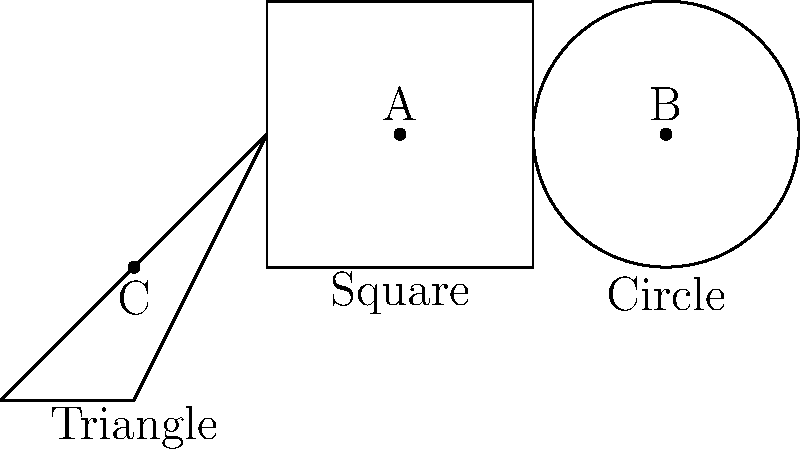As a retired firefighter with an eye for both functionality and architecture, you're consulting on the design of a new fire station. Three floor plan shapes are proposed: a square, a circle, and an equilateral triangle, each with the same area of 100 m². If point A is the center of the square, B is the center of the circle, and C is the centroid of the triangle, which shape would allow for the quickest average response time, assuming firefighters start from the center point? To determine the shape with the quickest average response time, we need to compare the average distance from the center to any point within each shape. This is related to the concept of the "mean radius" for each shape.

1. Square:
   - Side length: $\sqrt{100} = 10$ m
   - Mean radius ≈ 0.383 × side length
   - Mean radius ≈ 0.383 × 10 ≈ 3.83 m

2. Circle:
   - Radius: $r = \sqrt{\frac{100}{\pi}} ≈ 5.64$ m
   - Mean radius = $\frac{2}{3}r ≈ 3.76$ m

3. Equilateral Triangle:
   - Side length: $s = \sqrt{\frac{4}{\sqrt{3}} × 100} ≈ 15.19$ m
   - Mean radius ≈ 0.399 × side length
   - Mean radius ≈ 0.399 × 15.19 ≈ 6.06 m

The shape with the smallest mean radius will allow for the quickest average response time. In this case, the circle has the smallest mean radius of approximately 3.76 m.
Answer: Circle 